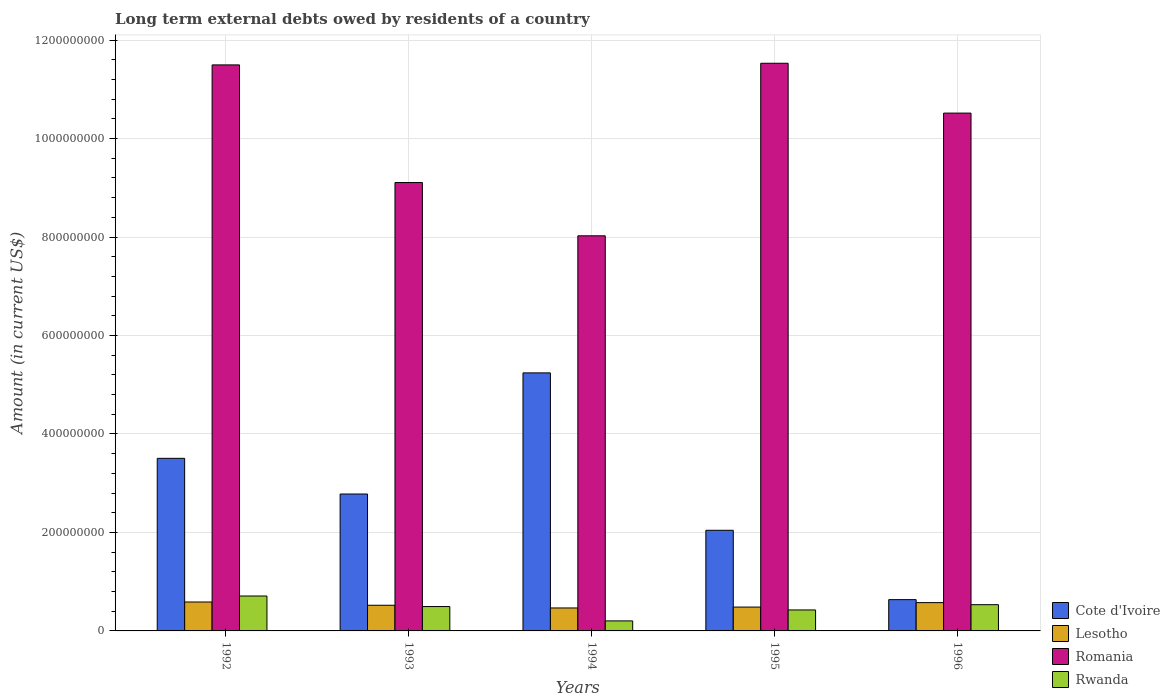How many groups of bars are there?
Make the answer very short. 5. How many bars are there on the 4th tick from the right?
Your answer should be compact. 4. What is the amount of long-term external debts owed by residents in Lesotho in 1993?
Your response must be concise. 5.21e+07. Across all years, what is the maximum amount of long-term external debts owed by residents in Lesotho?
Keep it short and to the point. 5.87e+07. Across all years, what is the minimum amount of long-term external debts owed by residents in Cote d'Ivoire?
Offer a very short reply. 6.35e+07. In which year was the amount of long-term external debts owed by residents in Lesotho maximum?
Provide a short and direct response. 1992. What is the total amount of long-term external debts owed by residents in Rwanda in the graph?
Give a very brief answer. 2.37e+08. What is the difference between the amount of long-term external debts owed by residents in Lesotho in 1992 and that in 1993?
Provide a succinct answer. 6.62e+06. What is the difference between the amount of long-term external debts owed by residents in Rwanda in 1996 and the amount of long-term external debts owed by residents in Romania in 1994?
Ensure brevity in your answer.  -7.49e+08. What is the average amount of long-term external debts owed by residents in Rwanda per year?
Give a very brief answer. 4.73e+07. In the year 1996, what is the difference between the amount of long-term external debts owed by residents in Romania and amount of long-term external debts owed by residents in Rwanda?
Offer a very short reply. 9.98e+08. In how many years, is the amount of long-term external debts owed by residents in Romania greater than 360000000 US$?
Offer a very short reply. 5. What is the ratio of the amount of long-term external debts owed by residents in Cote d'Ivoire in 1992 to that in 1993?
Ensure brevity in your answer.  1.26. Is the amount of long-term external debts owed by residents in Cote d'Ivoire in 1993 less than that in 1996?
Offer a terse response. No. Is the difference between the amount of long-term external debts owed by residents in Romania in 1992 and 1995 greater than the difference between the amount of long-term external debts owed by residents in Rwanda in 1992 and 1995?
Make the answer very short. No. What is the difference between the highest and the second highest amount of long-term external debts owed by residents in Rwanda?
Keep it short and to the point. 1.76e+07. What is the difference between the highest and the lowest amount of long-term external debts owed by residents in Rwanda?
Offer a very short reply. 5.05e+07. Is it the case that in every year, the sum of the amount of long-term external debts owed by residents in Cote d'Ivoire and amount of long-term external debts owed by residents in Romania is greater than the sum of amount of long-term external debts owed by residents in Lesotho and amount of long-term external debts owed by residents in Rwanda?
Offer a very short reply. Yes. What does the 3rd bar from the left in 1994 represents?
Make the answer very short. Romania. What does the 2nd bar from the right in 1993 represents?
Provide a succinct answer. Romania. How many bars are there?
Your answer should be compact. 20. Are all the bars in the graph horizontal?
Make the answer very short. No. Does the graph contain any zero values?
Your answer should be compact. No. Does the graph contain grids?
Offer a terse response. Yes. Where does the legend appear in the graph?
Make the answer very short. Bottom right. How many legend labels are there?
Offer a very short reply. 4. How are the legend labels stacked?
Keep it short and to the point. Vertical. What is the title of the graph?
Keep it short and to the point. Long term external debts owed by residents of a country. Does "Comoros" appear as one of the legend labels in the graph?
Ensure brevity in your answer.  No. What is the Amount (in current US$) in Cote d'Ivoire in 1992?
Your answer should be compact. 3.51e+08. What is the Amount (in current US$) of Lesotho in 1992?
Offer a very short reply. 5.87e+07. What is the Amount (in current US$) of Romania in 1992?
Offer a terse response. 1.15e+09. What is the Amount (in current US$) in Rwanda in 1992?
Make the answer very short. 7.09e+07. What is the Amount (in current US$) in Cote d'Ivoire in 1993?
Keep it short and to the point. 2.78e+08. What is the Amount (in current US$) of Lesotho in 1993?
Ensure brevity in your answer.  5.21e+07. What is the Amount (in current US$) in Romania in 1993?
Your answer should be very brief. 9.11e+08. What is the Amount (in current US$) in Rwanda in 1993?
Offer a terse response. 4.95e+07. What is the Amount (in current US$) in Cote d'Ivoire in 1994?
Your response must be concise. 5.24e+08. What is the Amount (in current US$) of Lesotho in 1994?
Your answer should be compact. 4.66e+07. What is the Amount (in current US$) of Romania in 1994?
Give a very brief answer. 8.02e+08. What is the Amount (in current US$) of Rwanda in 1994?
Your answer should be compact. 2.04e+07. What is the Amount (in current US$) of Cote d'Ivoire in 1995?
Make the answer very short. 2.04e+08. What is the Amount (in current US$) in Lesotho in 1995?
Your answer should be compact. 4.84e+07. What is the Amount (in current US$) of Romania in 1995?
Ensure brevity in your answer.  1.15e+09. What is the Amount (in current US$) of Rwanda in 1995?
Your response must be concise. 4.26e+07. What is the Amount (in current US$) in Cote d'Ivoire in 1996?
Your answer should be very brief. 6.35e+07. What is the Amount (in current US$) in Lesotho in 1996?
Provide a short and direct response. 5.75e+07. What is the Amount (in current US$) of Romania in 1996?
Offer a terse response. 1.05e+09. What is the Amount (in current US$) of Rwanda in 1996?
Provide a short and direct response. 5.33e+07. Across all years, what is the maximum Amount (in current US$) in Cote d'Ivoire?
Your answer should be compact. 5.24e+08. Across all years, what is the maximum Amount (in current US$) of Lesotho?
Give a very brief answer. 5.87e+07. Across all years, what is the maximum Amount (in current US$) of Romania?
Provide a succinct answer. 1.15e+09. Across all years, what is the maximum Amount (in current US$) in Rwanda?
Make the answer very short. 7.09e+07. Across all years, what is the minimum Amount (in current US$) of Cote d'Ivoire?
Keep it short and to the point. 6.35e+07. Across all years, what is the minimum Amount (in current US$) in Lesotho?
Offer a terse response. 4.66e+07. Across all years, what is the minimum Amount (in current US$) in Romania?
Make the answer very short. 8.02e+08. Across all years, what is the minimum Amount (in current US$) of Rwanda?
Give a very brief answer. 2.04e+07. What is the total Amount (in current US$) in Cote d'Ivoire in the graph?
Ensure brevity in your answer.  1.42e+09. What is the total Amount (in current US$) of Lesotho in the graph?
Offer a terse response. 2.63e+08. What is the total Amount (in current US$) in Romania in the graph?
Your response must be concise. 5.07e+09. What is the total Amount (in current US$) in Rwanda in the graph?
Keep it short and to the point. 2.37e+08. What is the difference between the Amount (in current US$) of Cote d'Ivoire in 1992 and that in 1993?
Make the answer very short. 7.24e+07. What is the difference between the Amount (in current US$) in Lesotho in 1992 and that in 1993?
Provide a succinct answer. 6.62e+06. What is the difference between the Amount (in current US$) of Romania in 1992 and that in 1993?
Your response must be concise. 2.39e+08. What is the difference between the Amount (in current US$) in Rwanda in 1992 and that in 1993?
Make the answer very short. 2.14e+07. What is the difference between the Amount (in current US$) of Cote d'Ivoire in 1992 and that in 1994?
Your answer should be very brief. -1.74e+08. What is the difference between the Amount (in current US$) of Lesotho in 1992 and that in 1994?
Provide a succinct answer. 1.21e+07. What is the difference between the Amount (in current US$) of Romania in 1992 and that in 1994?
Offer a terse response. 3.47e+08. What is the difference between the Amount (in current US$) of Rwanda in 1992 and that in 1994?
Offer a very short reply. 5.05e+07. What is the difference between the Amount (in current US$) in Cote d'Ivoire in 1992 and that in 1995?
Provide a succinct answer. 1.46e+08. What is the difference between the Amount (in current US$) in Lesotho in 1992 and that in 1995?
Provide a short and direct response. 1.03e+07. What is the difference between the Amount (in current US$) in Romania in 1992 and that in 1995?
Keep it short and to the point. -3.33e+06. What is the difference between the Amount (in current US$) of Rwanda in 1992 and that in 1995?
Offer a terse response. 2.83e+07. What is the difference between the Amount (in current US$) of Cote d'Ivoire in 1992 and that in 1996?
Offer a very short reply. 2.87e+08. What is the difference between the Amount (in current US$) in Lesotho in 1992 and that in 1996?
Offer a terse response. 1.27e+06. What is the difference between the Amount (in current US$) of Romania in 1992 and that in 1996?
Ensure brevity in your answer.  9.79e+07. What is the difference between the Amount (in current US$) of Rwanda in 1992 and that in 1996?
Give a very brief answer. 1.76e+07. What is the difference between the Amount (in current US$) of Cote d'Ivoire in 1993 and that in 1994?
Offer a terse response. -2.46e+08. What is the difference between the Amount (in current US$) in Lesotho in 1993 and that in 1994?
Your response must be concise. 5.50e+06. What is the difference between the Amount (in current US$) of Romania in 1993 and that in 1994?
Offer a terse response. 1.08e+08. What is the difference between the Amount (in current US$) of Rwanda in 1993 and that in 1994?
Make the answer very short. 2.91e+07. What is the difference between the Amount (in current US$) of Cote d'Ivoire in 1993 and that in 1995?
Your answer should be compact. 7.37e+07. What is the difference between the Amount (in current US$) in Lesotho in 1993 and that in 1995?
Make the answer very short. 3.68e+06. What is the difference between the Amount (in current US$) of Romania in 1993 and that in 1995?
Ensure brevity in your answer.  -2.42e+08. What is the difference between the Amount (in current US$) of Rwanda in 1993 and that in 1995?
Your answer should be compact. 6.87e+06. What is the difference between the Amount (in current US$) of Cote d'Ivoire in 1993 and that in 1996?
Make the answer very short. 2.15e+08. What is the difference between the Amount (in current US$) in Lesotho in 1993 and that in 1996?
Your response must be concise. -5.35e+06. What is the difference between the Amount (in current US$) of Romania in 1993 and that in 1996?
Provide a succinct answer. -1.41e+08. What is the difference between the Amount (in current US$) of Rwanda in 1993 and that in 1996?
Your answer should be compact. -3.83e+06. What is the difference between the Amount (in current US$) in Cote d'Ivoire in 1994 and that in 1995?
Your answer should be very brief. 3.20e+08. What is the difference between the Amount (in current US$) of Lesotho in 1994 and that in 1995?
Your answer should be very brief. -1.82e+06. What is the difference between the Amount (in current US$) in Romania in 1994 and that in 1995?
Keep it short and to the point. -3.50e+08. What is the difference between the Amount (in current US$) of Rwanda in 1994 and that in 1995?
Provide a short and direct response. -2.22e+07. What is the difference between the Amount (in current US$) in Cote d'Ivoire in 1994 and that in 1996?
Your answer should be compact. 4.61e+08. What is the difference between the Amount (in current US$) in Lesotho in 1994 and that in 1996?
Your response must be concise. -1.09e+07. What is the difference between the Amount (in current US$) of Romania in 1994 and that in 1996?
Make the answer very short. -2.49e+08. What is the difference between the Amount (in current US$) of Rwanda in 1994 and that in 1996?
Ensure brevity in your answer.  -3.29e+07. What is the difference between the Amount (in current US$) in Cote d'Ivoire in 1995 and that in 1996?
Your answer should be compact. 1.41e+08. What is the difference between the Amount (in current US$) of Lesotho in 1995 and that in 1996?
Keep it short and to the point. -9.03e+06. What is the difference between the Amount (in current US$) in Romania in 1995 and that in 1996?
Offer a terse response. 1.01e+08. What is the difference between the Amount (in current US$) in Rwanda in 1995 and that in 1996?
Offer a very short reply. -1.07e+07. What is the difference between the Amount (in current US$) in Cote d'Ivoire in 1992 and the Amount (in current US$) in Lesotho in 1993?
Give a very brief answer. 2.98e+08. What is the difference between the Amount (in current US$) in Cote d'Ivoire in 1992 and the Amount (in current US$) in Romania in 1993?
Make the answer very short. -5.60e+08. What is the difference between the Amount (in current US$) of Cote d'Ivoire in 1992 and the Amount (in current US$) of Rwanda in 1993?
Provide a succinct answer. 3.01e+08. What is the difference between the Amount (in current US$) of Lesotho in 1992 and the Amount (in current US$) of Romania in 1993?
Provide a succinct answer. -8.52e+08. What is the difference between the Amount (in current US$) in Lesotho in 1992 and the Amount (in current US$) in Rwanda in 1993?
Your answer should be very brief. 9.28e+06. What is the difference between the Amount (in current US$) of Romania in 1992 and the Amount (in current US$) of Rwanda in 1993?
Keep it short and to the point. 1.10e+09. What is the difference between the Amount (in current US$) of Cote d'Ivoire in 1992 and the Amount (in current US$) of Lesotho in 1994?
Ensure brevity in your answer.  3.04e+08. What is the difference between the Amount (in current US$) in Cote d'Ivoire in 1992 and the Amount (in current US$) in Romania in 1994?
Your answer should be very brief. -4.52e+08. What is the difference between the Amount (in current US$) of Cote d'Ivoire in 1992 and the Amount (in current US$) of Rwanda in 1994?
Ensure brevity in your answer.  3.30e+08. What is the difference between the Amount (in current US$) in Lesotho in 1992 and the Amount (in current US$) in Romania in 1994?
Give a very brief answer. -7.44e+08. What is the difference between the Amount (in current US$) in Lesotho in 1992 and the Amount (in current US$) in Rwanda in 1994?
Give a very brief answer. 3.84e+07. What is the difference between the Amount (in current US$) in Romania in 1992 and the Amount (in current US$) in Rwanda in 1994?
Ensure brevity in your answer.  1.13e+09. What is the difference between the Amount (in current US$) in Cote d'Ivoire in 1992 and the Amount (in current US$) in Lesotho in 1995?
Your answer should be very brief. 3.02e+08. What is the difference between the Amount (in current US$) in Cote d'Ivoire in 1992 and the Amount (in current US$) in Romania in 1995?
Offer a terse response. -8.02e+08. What is the difference between the Amount (in current US$) in Cote d'Ivoire in 1992 and the Amount (in current US$) in Rwanda in 1995?
Provide a succinct answer. 3.08e+08. What is the difference between the Amount (in current US$) in Lesotho in 1992 and the Amount (in current US$) in Romania in 1995?
Make the answer very short. -1.09e+09. What is the difference between the Amount (in current US$) in Lesotho in 1992 and the Amount (in current US$) in Rwanda in 1995?
Your answer should be compact. 1.61e+07. What is the difference between the Amount (in current US$) in Romania in 1992 and the Amount (in current US$) in Rwanda in 1995?
Give a very brief answer. 1.11e+09. What is the difference between the Amount (in current US$) in Cote d'Ivoire in 1992 and the Amount (in current US$) in Lesotho in 1996?
Ensure brevity in your answer.  2.93e+08. What is the difference between the Amount (in current US$) of Cote d'Ivoire in 1992 and the Amount (in current US$) of Romania in 1996?
Offer a terse response. -7.01e+08. What is the difference between the Amount (in current US$) of Cote d'Ivoire in 1992 and the Amount (in current US$) of Rwanda in 1996?
Offer a very short reply. 2.97e+08. What is the difference between the Amount (in current US$) in Lesotho in 1992 and the Amount (in current US$) in Romania in 1996?
Your response must be concise. -9.93e+08. What is the difference between the Amount (in current US$) in Lesotho in 1992 and the Amount (in current US$) in Rwanda in 1996?
Your answer should be compact. 5.45e+06. What is the difference between the Amount (in current US$) of Romania in 1992 and the Amount (in current US$) of Rwanda in 1996?
Your answer should be very brief. 1.10e+09. What is the difference between the Amount (in current US$) of Cote d'Ivoire in 1993 and the Amount (in current US$) of Lesotho in 1994?
Your answer should be compact. 2.31e+08. What is the difference between the Amount (in current US$) in Cote d'Ivoire in 1993 and the Amount (in current US$) in Romania in 1994?
Your answer should be very brief. -5.24e+08. What is the difference between the Amount (in current US$) in Cote d'Ivoire in 1993 and the Amount (in current US$) in Rwanda in 1994?
Your response must be concise. 2.58e+08. What is the difference between the Amount (in current US$) in Lesotho in 1993 and the Amount (in current US$) in Romania in 1994?
Keep it short and to the point. -7.50e+08. What is the difference between the Amount (in current US$) in Lesotho in 1993 and the Amount (in current US$) in Rwanda in 1994?
Offer a very short reply. 3.18e+07. What is the difference between the Amount (in current US$) of Romania in 1993 and the Amount (in current US$) of Rwanda in 1994?
Offer a very short reply. 8.90e+08. What is the difference between the Amount (in current US$) of Cote d'Ivoire in 1993 and the Amount (in current US$) of Lesotho in 1995?
Give a very brief answer. 2.30e+08. What is the difference between the Amount (in current US$) in Cote d'Ivoire in 1993 and the Amount (in current US$) in Romania in 1995?
Give a very brief answer. -8.75e+08. What is the difference between the Amount (in current US$) in Cote d'Ivoire in 1993 and the Amount (in current US$) in Rwanda in 1995?
Make the answer very short. 2.35e+08. What is the difference between the Amount (in current US$) of Lesotho in 1993 and the Amount (in current US$) of Romania in 1995?
Make the answer very short. -1.10e+09. What is the difference between the Amount (in current US$) of Lesotho in 1993 and the Amount (in current US$) of Rwanda in 1995?
Make the answer very short. 9.52e+06. What is the difference between the Amount (in current US$) of Romania in 1993 and the Amount (in current US$) of Rwanda in 1995?
Give a very brief answer. 8.68e+08. What is the difference between the Amount (in current US$) of Cote d'Ivoire in 1993 and the Amount (in current US$) of Lesotho in 1996?
Give a very brief answer. 2.21e+08. What is the difference between the Amount (in current US$) of Cote d'Ivoire in 1993 and the Amount (in current US$) of Romania in 1996?
Your answer should be very brief. -7.74e+08. What is the difference between the Amount (in current US$) of Cote d'Ivoire in 1993 and the Amount (in current US$) of Rwanda in 1996?
Keep it short and to the point. 2.25e+08. What is the difference between the Amount (in current US$) of Lesotho in 1993 and the Amount (in current US$) of Romania in 1996?
Ensure brevity in your answer.  -1.00e+09. What is the difference between the Amount (in current US$) of Lesotho in 1993 and the Amount (in current US$) of Rwanda in 1996?
Your answer should be compact. -1.17e+06. What is the difference between the Amount (in current US$) in Romania in 1993 and the Amount (in current US$) in Rwanda in 1996?
Give a very brief answer. 8.57e+08. What is the difference between the Amount (in current US$) in Cote d'Ivoire in 1994 and the Amount (in current US$) in Lesotho in 1995?
Offer a terse response. 4.76e+08. What is the difference between the Amount (in current US$) of Cote d'Ivoire in 1994 and the Amount (in current US$) of Romania in 1995?
Your answer should be very brief. -6.29e+08. What is the difference between the Amount (in current US$) of Cote d'Ivoire in 1994 and the Amount (in current US$) of Rwanda in 1995?
Offer a very short reply. 4.81e+08. What is the difference between the Amount (in current US$) in Lesotho in 1994 and the Amount (in current US$) in Romania in 1995?
Provide a succinct answer. -1.11e+09. What is the difference between the Amount (in current US$) in Lesotho in 1994 and the Amount (in current US$) in Rwanda in 1995?
Provide a succinct answer. 4.02e+06. What is the difference between the Amount (in current US$) in Romania in 1994 and the Amount (in current US$) in Rwanda in 1995?
Give a very brief answer. 7.60e+08. What is the difference between the Amount (in current US$) of Cote d'Ivoire in 1994 and the Amount (in current US$) of Lesotho in 1996?
Make the answer very short. 4.67e+08. What is the difference between the Amount (in current US$) of Cote d'Ivoire in 1994 and the Amount (in current US$) of Romania in 1996?
Ensure brevity in your answer.  -5.28e+08. What is the difference between the Amount (in current US$) of Cote d'Ivoire in 1994 and the Amount (in current US$) of Rwanda in 1996?
Offer a very short reply. 4.71e+08. What is the difference between the Amount (in current US$) in Lesotho in 1994 and the Amount (in current US$) in Romania in 1996?
Your answer should be compact. -1.01e+09. What is the difference between the Amount (in current US$) in Lesotho in 1994 and the Amount (in current US$) in Rwanda in 1996?
Your answer should be very brief. -6.67e+06. What is the difference between the Amount (in current US$) in Romania in 1994 and the Amount (in current US$) in Rwanda in 1996?
Give a very brief answer. 7.49e+08. What is the difference between the Amount (in current US$) of Cote d'Ivoire in 1995 and the Amount (in current US$) of Lesotho in 1996?
Your answer should be very brief. 1.47e+08. What is the difference between the Amount (in current US$) in Cote d'Ivoire in 1995 and the Amount (in current US$) in Romania in 1996?
Your response must be concise. -8.47e+08. What is the difference between the Amount (in current US$) of Cote d'Ivoire in 1995 and the Amount (in current US$) of Rwanda in 1996?
Ensure brevity in your answer.  1.51e+08. What is the difference between the Amount (in current US$) in Lesotho in 1995 and the Amount (in current US$) in Romania in 1996?
Make the answer very short. -1.00e+09. What is the difference between the Amount (in current US$) of Lesotho in 1995 and the Amount (in current US$) of Rwanda in 1996?
Provide a succinct answer. -4.85e+06. What is the difference between the Amount (in current US$) of Romania in 1995 and the Amount (in current US$) of Rwanda in 1996?
Make the answer very short. 1.10e+09. What is the average Amount (in current US$) of Cote d'Ivoire per year?
Give a very brief answer. 2.84e+08. What is the average Amount (in current US$) in Lesotho per year?
Your answer should be compact. 5.27e+07. What is the average Amount (in current US$) in Romania per year?
Give a very brief answer. 1.01e+09. What is the average Amount (in current US$) of Rwanda per year?
Provide a succinct answer. 4.73e+07. In the year 1992, what is the difference between the Amount (in current US$) of Cote d'Ivoire and Amount (in current US$) of Lesotho?
Offer a very short reply. 2.92e+08. In the year 1992, what is the difference between the Amount (in current US$) of Cote d'Ivoire and Amount (in current US$) of Romania?
Make the answer very short. -7.99e+08. In the year 1992, what is the difference between the Amount (in current US$) in Cote d'Ivoire and Amount (in current US$) in Rwanda?
Ensure brevity in your answer.  2.80e+08. In the year 1992, what is the difference between the Amount (in current US$) in Lesotho and Amount (in current US$) in Romania?
Offer a terse response. -1.09e+09. In the year 1992, what is the difference between the Amount (in current US$) of Lesotho and Amount (in current US$) of Rwanda?
Give a very brief answer. -1.22e+07. In the year 1992, what is the difference between the Amount (in current US$) of Romania and Amount (in current US$) of Rwanda?
Provide a short and direct response. 1.08e+09. In the year 1993, what is the difference between the Amount (in current US$) of Cote d'Ivoire and Amount (in current US$) of Lesotho?
Your answer should be compact. 2.26e+08. In the year 1993, what is the difference between the Amount (in current US$) of Cote d'Ivoire and Amount (in current US$) of Romania?
Ensure brevity in your answer.  -6.33e+08. In the year 1993, what is the difference between the Amount (in current US$) in Cote d'Ivoire and Amount (in current US$) in Rwanda?
Provide a succinct answer. 2.29e+08. In the year 1993, what is the difference between the Amount (in current US$) in Lesotho and Amount (in current US$) in Romania?
Provide a short and direct response. -8.58e+08. In the year 1993, what is the difference between the Amount (in current US$) of Lesotho and Amount (in current US$) of Rwanda?
Give a very brief answer. 2.65e+06. In the year 1993, what is the difference between the Amount (in current US$) of Romania and Amount (in current US$) of Rwanda?
Provide a succinct answer. 8.61e+08. In the year 1994, what is the difference between the Amount (in current US$) of Cote d'Ivoire and Amount (in current US$) of Lesotho?
Provide a succinct answer. 4.77e+08. In the year 1994, what is the difference between the Amount (in current US$) of Cote d'Ivoire and Amount (in current US$) of Romania?
Make the answer very short. -2.78e+08. In the year 1994, what is the difference between the Amount (in current US$) in Cote d'Ivoire and Amount (in current US$) in Rwanda?
Provide a short and direct response. 5.04e+08. In the year 1994, what is the difference between the Amount (in current US$) in Lesotho and Amount (in current US$) in Romania?
Offer a very short reply. -7.56e+08. In the year 1994, what is the difference between the Amount (in current US$) in Lesotho and Amount (in current US$) in Rwanda?
Your response must be concise. 2.63e+07. In the year 1994, what is the difference between the Amount (in current US$) of Romania and Amount (in current US$) of Rwanda?
Your response must be concise. 7.82e+08. In the year 1995, what is the difference between the Amount (in current US$) of Cote d'Ivoire and Amount (in current US$) of Lesotho?
Offer a very short reply. 1.56e+08. In the year 1995, what is the difference between the Amount (in current US$) of Cote d'Ivoire and Amount (in current US$) of Romania?
Keep it short and to the point. -9.48e+08. In the year 1995, what is the difference between the Amount (in current US$) in Cote d'Ivoire and Amount (in current US$) in Rwanda?
Give a very brief answer. 1.62e+08. In the year 1995, what is the difference between the Amount (in current US$) of Lesotho and Amount (in current US$) of Romania?
Offer a terse response. -1.10e+09. In the year 1995, what is the difference between the Amount (in current US$) in Lesotho and Amount (in current US$) in Rwanda?
Keep it short and to the point. 5.84e+06. In the year 1995, what is the difference between the Amount (in current US$) in Romania and Amount (in current US$) in Rwanda?
Give a very brief answer. 1.11e+09. In the year 1996, what is the difference between the Amount (in current US$) in Cote d'Ivoire and Amount (in current US$) in Lesotho?
Offer a very short reply. 6.06e+06. In the year 1996, what is the difference between the Amount (in current US$) in Cote d'Ivoire and Amount (in current US$) in Romania?
Offer a terse response. -9.88e+08. In the year 1996, what is the difference between the Amount (in current US$) in Cote d'Ivoire and Amount (in current US$) in Rwanda?
Give a very brief answer. 1.02e+07. In the year 1996, what is the difference between the Amount (in current US$) of Lesotho and Amount (in current US$) of Romania?
Your response must be concise. -9.94e+08. In the year 1996, what is the difference between the Amount (in current US$) in Lesotho and Amount (in current US$) in Rwanda?
Provide a short and direct response. 4.18e+06. In the year 1996, what is the difference between the Amount (in current US$) in Romania and Amount (in current US$) in Rwanda?
Keep it short and to the point. 9.98e+08. What is the ratio of the Amount (in current US$) of Cote d'Ivoire in 1992 to that in 1993?
Keep it short and to the point. 1.26. What is the ratio of the Amount (in current US$) of Lesotho in 1992 to that in 1993?
Make the answer very short. 1.13. What is the ratio of the Amount (in current US$) in Romania in 1992 to that in 1993?
Provide a succinct answer. 1.26. What is the ratio of the Amount (in current US$) in Rwanda in 1992 to that in 1993?
Provide a succinct answer. 1.43. What is the ratio of the Amount (in current US$) of Cote d'Ivoire in 1992 to that in 1994?
Your answer should be compact. 0.67. What is the ratio of the Amount (in current US$) of Lesotho in 1992 to that in 1994?
Offer a terse response. 1.26. What is the ratio of the Amount (in current US$) in Romania in 1992 to that in 1994?
Give a very brief answer. 1.43. What is the ratio of the Amount (in current US$) in Rwanda in 1992 to that in 1994?
Ensure brevity in your answer.  3.48. What is the ratio of the Amount (in current US$) of Cote d'Ivoire in 1992 to that in 1995?
Your response must be concise. 1.72. What is the ratio of the Amount (in current US$) in Lesotho in 1992 to that in 1995?
Provide a short and direct response. 1.21. What is the ratio of the Amount (in current US$) in Rwanda in 1992 to that in 1995?
Give a very brief answer. 1.66. What is the ratio of the Amount (in current US$) in Cote d'Ivoire in 1992 to that in 1996?
Make the answer very short. 5.52. What is the ratio of the Amount (in current US$) in Lesotho in 1992 to that in 1996?
Make the answer very short. 1.02. What is the ratio of the Amount (in current US$) in Romania in 1992 to that in 1996?
Provide a short and direct response. 1.09. What is the ratio of the Amount (in current US$) in Rwanda in 1992 to that in 1996?
Your response must be concise. 1.33. What is the ratio of the Amount (in current US$) of Cote d'Ivoire in 1993 to that in 1994?
Keep it short and to the point. 0.53. What is the ratio of the Amount (in current US$) in Lesotho in 1993 to that in 1994?
Make the answer very short. 1.12. What is the ratio of the Amount (in current US$) in Romania in 1993 to that in 1994?
Ensure brevity in your answer.  1.13. What is the ratio of the Amount (in current US$) of Rwanda in 1993 to that in 1994?
Offer a very short reply. 2.43. What is the ratio of the Amount (in current US$) in Cote d'Ivoire in 1993 to that in 1995?
Your answer should be very brief. 1.36. What is the ratio of the Amount (in current US$) in Lesotho in 1993 to that in 1995?
Offer a very short reply. 1.08. What is the ratio of the Amount (in current US$) of Romania in 1993 to that in 1995?
Your answer should be very brief. 0.79. What is the ratio of the Amount (in current US$) in Rwanda in 1993 to that in 1995?
Provide a succinct answer. 1.16. What is the ratio of the Amount (in current US$) of Cote d'Ivoire in 1993 to that in 1996?
Ensure brevity in your answer.  4.38. What is the ratio of the Amount (in current US$) of Lesotho in 1993 to that in 1996?
Provide a short and direct response. 0.91. What is the ratio of the Amount (in current US$) of Romania in 1993 to that in 1996?
Offer a very short reply. 0.87. What is the ratio of the Amount (in current US$) of Rwanda in 1993 to that in 1996?
Your answer should be compact. 0.93. What is the ratio of the Amount (in current US$) in Cote d'Ivoire in 1994 to that in 1995?
Your response must be concise. 2.56. What is the ratio of the Amount (in current US$) of Lesotho in 1994 to that in 1995?
Your answer should be compact. 0.96. What is the ratio of the Amount (in current US$) of Romania in 1994 to that in 1995?
Make the answer very short. 0.7. What is the ratio of the Amount (in current US$) in Rwanda in 1994 to that in 1995?
Offer a terse response. 0.48. What is the ratio of the Amount (in current US$) of Cote d'Ivoire in 1994 to that in 1996?
Offer a very short reply. 8.25. What is the ratio of the Amount (in current US$) of Lesotho in 1994 to that in 1996?
Give a very brief answer. 0.81. What is the ratio of the Amount (in current US$) of Romania in 1994 to that in 1996?
Offer a very short reply. 0.76. What is the ratio of the Amount (in current US$) in Rwanda in 1994 to that in 1996?
Give a very brief answer. 0.38. What is the ratio of the Amount (in current US$) in Cote d'Ivoire in 1995 to that in 1996?
Provide a succinct answer. 3.22. What is the ratio of the Amount (in current US$) of Lesotho in 1995 to that in 1996?
Give a very brief answer. 0.84. What is the ratio of the Amount (in current US$) in Romania in 1995 to that in 1996?
Ensure brevity in your answer.  1.1. What is the ratio of the Amount (in current US$) in Rwanda in 1995 to that in 1996?
Provide a short and direct response. 0.8. What is the difference between the highest and the second highest Amount (in current US$) in Cote d'Ivoire?
Give a very brief answer. 1.74e+08. What is the difference between the highest and the second highest Amount (in current US$) of Lesotho?
Your response must be concise. 1.27e+06. What is the difference between the highest and the second highest Amount (in current US$) of Romania?
Make the answer very short. 3.33e+06. What is the difference between the highest and the second highest Amount (in current US$) in Rwanda?
Provide a short and direct response. 1.76e+07. What is the difference between the highest and the lowest Amount (in current US$) of Cote d'Ivoire?
Your answer should be very brief. 4.61e+08. What is the difference between the highest and the lowest Amount (in current US$) in Lesotho?
Your answer should be compact. 1.21e+07. What is the difference between the highest and the lowest Amount (in current US$) in Romania?
Offer a terse response. 3.50e+08. What is the difference between the highest and the lowest Amount (in current US$) of Rwanda?
Provide a short and direct response. 5.05e+07. 